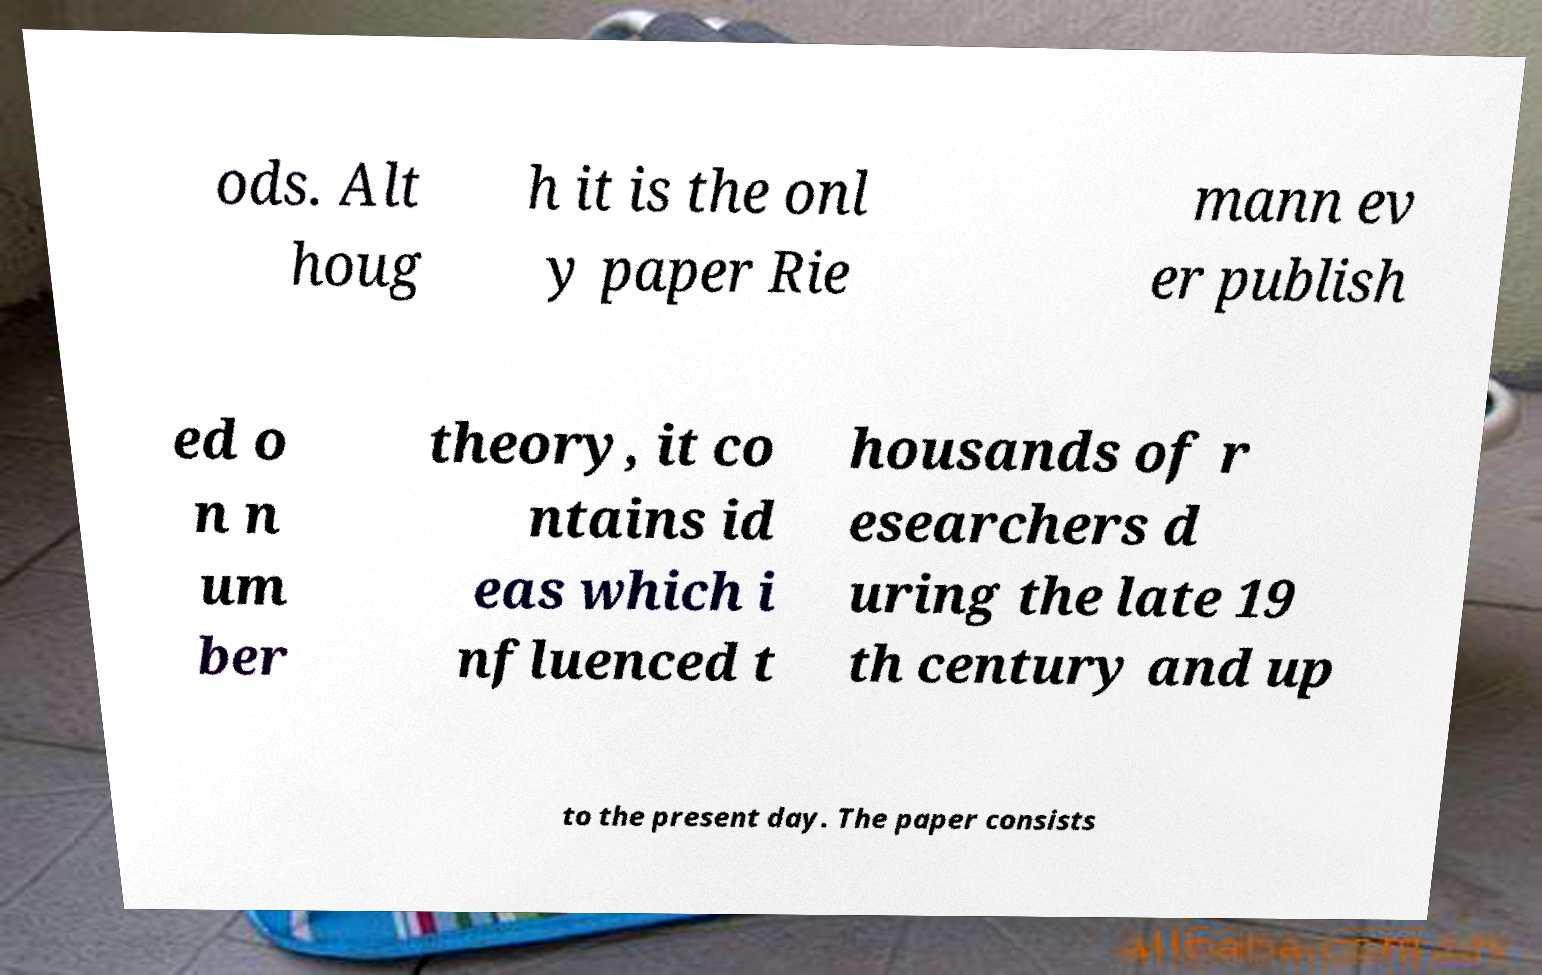There's text embedded in this image that I need extracted. Can you transcribe it verbatim? ods. Alt houg h it is the onl y paper Rie mann ev er publish ed o n n um ber theory, it co ntains id eas which i nfluenced t housands of r esearchers d uring the late 19 th century and up to the present day. The paper consists 